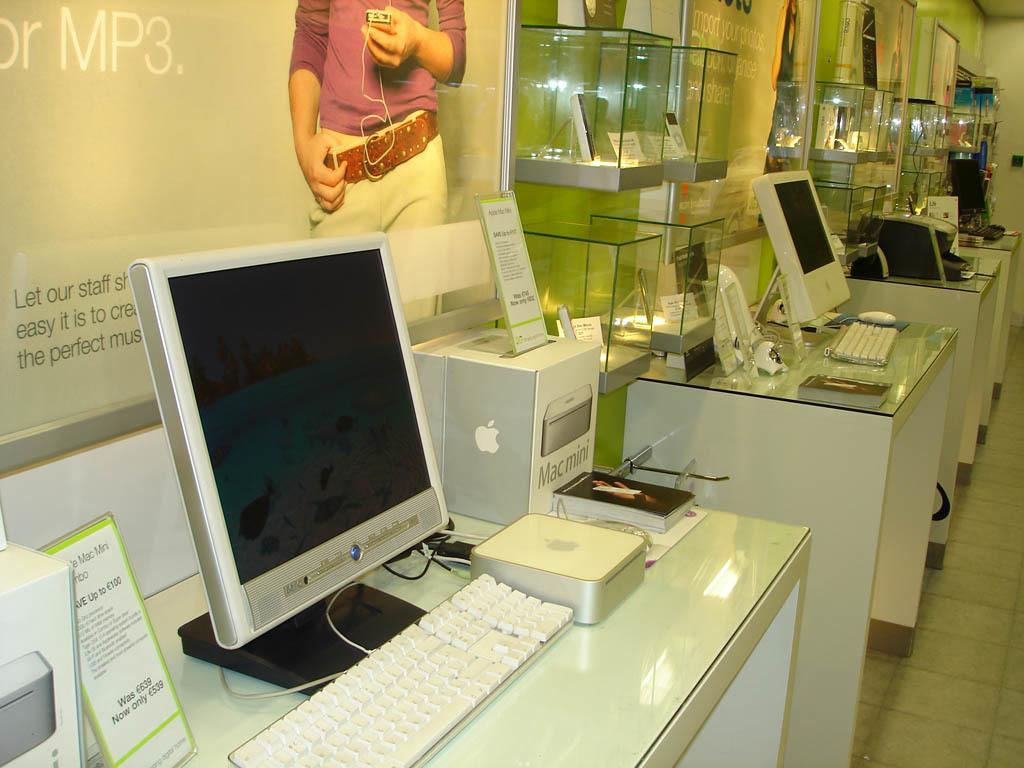<image>
Describe the image concisely. A sign about MP3 players is above some computers that are on display. 